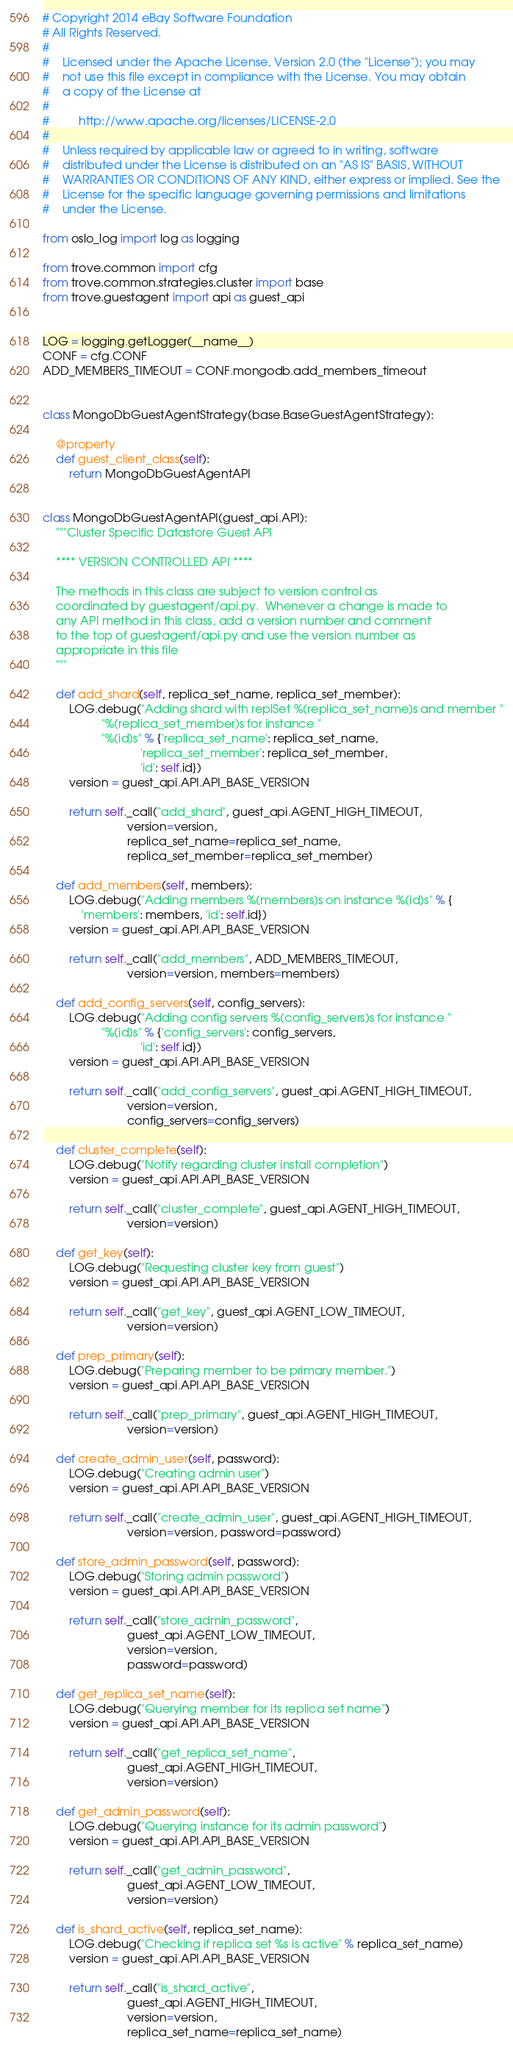Convert code to text. <code><loc_0><loc_0><loc_500><loc_500><_Python_># Copyright 2014 eBay Software Foundation
# All Rights Reserved.
#
#    Licensed under the Apache License, Version 2.0 (the "License"); you may
#    not use this file except in compliance with the License. You may obtain
#    a copy of the License at
#
#         http://www.apache.org/licenses/LICENSE-2.0
#
#    Unless required by applicable law or agreed to in writing, software
#    distributed under the License is distributed on an "AS IS" BASIS, WITHOUT
#    WARRANTIES OR CONDITIONS OF ANY KIND, either express or implied. See the
#    License for the specific language governing permissions and limitations
#    under the License.

from oslo_log import log as logging

from trove.common import cfg
from trove.common.strategies.cluster import base
from trove.guestagent import api as guest_api


LOG = logging.getLogger(__name__)
CONF = cfg.CONF
ADD_MEMBERS_TIMEOUT = CONF.mongodb.add_members_timeout


class MongoDbGuestAgentStrategy(base.BaseGuestAgentStrategy):

    @property
    def guest_client_class(self):
        return MongoDbGuestAgentAPI


class MongoDbGuestAgentAPI(guest_api.API):
    """Cluster Specific Datastore Guest API

    **** VERSION CONTROLLED API ****

    The methods in this class are subject to version control as
    coordinated by guestagent/api.py.  Whenever a change is made to
    any API method in this class, add a version number and comment
    to the top of guestagent/api.py and use the version number as
    appropriate in this file
    """

    def add_shard(self, replica_set_name, replica_set_member):
        LOG.debug("Adding shard with replSet %(replica_set_name)s and member "
                  "%(replica_set_member)s for instance "
                  "%(id)s" % {'replica_set_name': replica_set_name,
                              'replica_set_member': replica_set_member,
                              'id': self.id})
        version = guest_api.API.API_BASE_VERSION

        return self._call("add_shard", guest_api.AGENT_HIGH_TIMEOUT,
                          version=version,
                          replica_set_name=replica_set_name,
                          replica_set_member=replica_set_member)

    def add_members(self, members):
        LOG.debug("Adding members %(members)s on instance %(id)s" % {
            'members': members, 'id': self.id})
        version = guest_api.API.API_BASE_VERSION

        return self._call("add_members", ADD_MEMBERS_TIMEOUT,
                          version=version, members=members)

    def add_config_servers(self, config_servers):
        LOG.debug("Adding config servers %(config_servers)s for instance "
                  "%(id)s" % {'config_servers': config_servers,
                              'id': self.id})
        version = guest_api.API.API_BASE_VERSION

        return self._call("add_config_servers", guest_api.AGENT_HIGH_TIMEOUT,
                          version=version,
                          config_servers=config_servers)

    def cluster_complete(self):
        LOG.debug("Notify regarding cluster install completion")
        version = guest_api.API.API_BASE_VERSION

        return self._call("cluster_complete", guest_api.AGENT_HIGH_TIMEOUT,
                          version=version)

    def get_key(self):
        LOG.debug("Requesting cluster key from guest")
        version = guest_api.API.API_BASE_VERSION

        return self._call("get_key", guest_api.AGENT_LOW_TIMEOUT,
                          version=version)

    def prep_primary(self):
        LOG.debug("Preparing member to be primary member.")
        version = guest_api.API.API_BASE_VERSION

        return self._call("prep_primary", guest_api.AGENT_HIGH_TIMEOUT,
                          version=version)

    def create_admin_user(self, password):
        LOG.debug("Creating admin user")
        version = guest_api.API.API_BASE_VERSION

        return self._call("create_admin_user", guest_api.AGENT_HIGH_TIMEOUT,
                          version=version, password=password)

    def store_admin_password(self, password):
        LOG.debug("Storing admin password")
        version = guest_api.API.API_BASE_VERSION

        return self._call("store_admin_password",
                          guest_api.AGENT_LOW_TIMEOUT,
                          version=version,
                          password=password)

    def get_replica_set_name(self):
        LOG.debug("Querying member for its replica set name")
        version = guest_api.API.API_BASE_VERSION

        return self._call("get_replica_set_name",
                          guest_api.AGENT_HIGH_TIMEOUT,
                          version=version)

    def get_admin_password(self):
        LOG.debug("Querying instance for its admin password")
        version = guest_api.API.API_BASE_VERSION

        return self._call("get_admin_password",
                          guest_api.AGENT_LOW_TIMEOUT,
                          version=version)

    def is_shard_active(self, replica_set_name):
        LOG.debug("Checking if replica set %s is active" % replica_set_name)
        version = guest_api.API.API_BASE_VERSION

        return self._call("is_shard_active",
                          guest_api.AGENT_HIGH_TIMEOUT,
                          version=version,
                          replica_set_name=replica_set_name)
</code> 